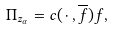<formula> <loc_0><loc_0><loc_500><loc_500>\Pi _ { z _ { \alpha } } = c ( \, \cdot \, , \overline { f } ) f ,</formula> 